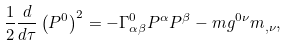Convert formula to latex. <formula><loc_0><loc_0><loc_500><loc_500>\frac { 1 } { 2 } \frac { d } { d \tau } \left ( P ^ { 0 } \right ) ^ { 2 } = - \Gamma ^ { 0 } _ { \alpha \beta } P ^ { \alpha } P ^ { \beta } - m g ^ { 0 \nu } m _ { , \nu } ,</formula> 